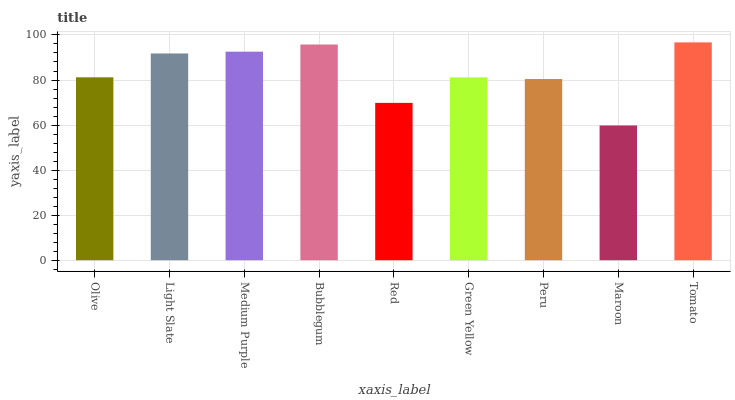Is Maroon the minimum?
Answer yes or no. Yes. Is Tomato the maximum?
Answer yes or no. Yes. Is Light Slate the minimum?
Answer yes or no. No. Is Light Slate the maximum?
Answer yes or no. No. Is Light Slate greater than Olive?
Answer yes or no. Yes. Is Olive less than Light Slate?
Answer yes or no. Yes. Is Olive greater than Light Slate?
Answer yes or no. No. Is Light Slate less than Olive?
Answer yes or no. No. Is Olive the high median?
Answer yes or no. Yes. Is Olive the low median?
Answer yes or no. Yes. Is Light Slate the high median?
Answer yes or no. No. Is Green Yellow the low median?
Answer yes or no. No. 